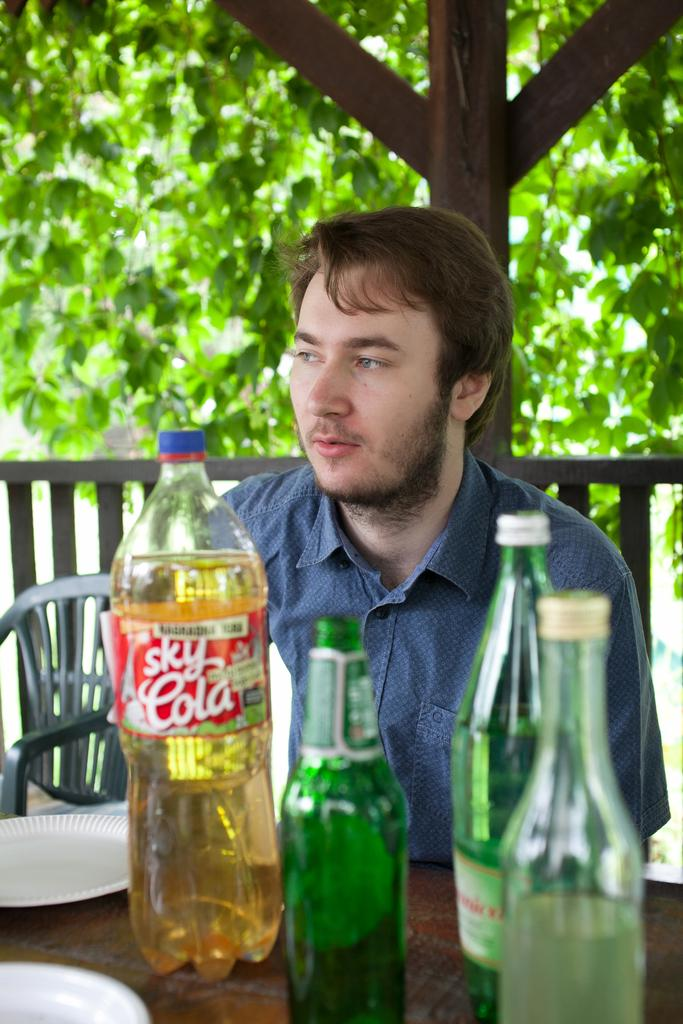<image>
Create a compact narrative representing the image presented. A man is sitting next to some bottles and one is labeled "Sky Cola". 